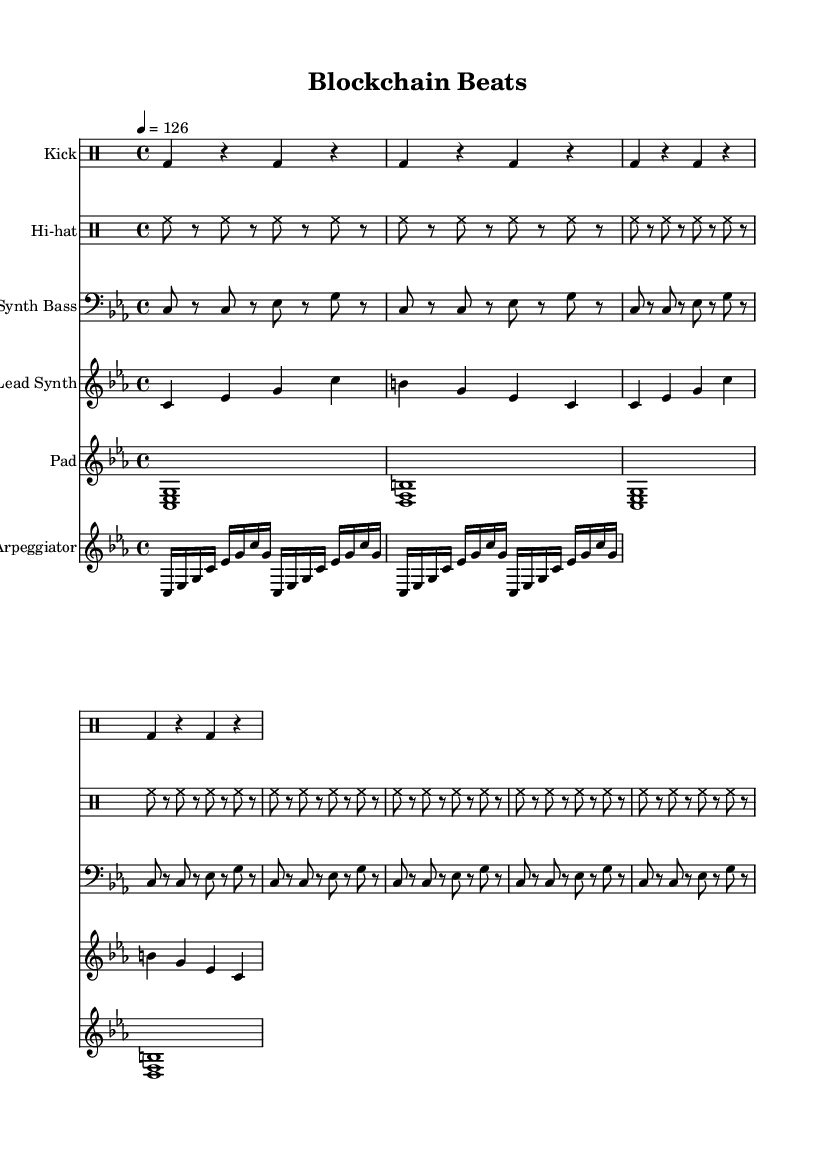What is the key signature of this music? The key signature is C minor, which indicates the presence of three flats (B♭, E♭, and A♭). You can identify it by checking the key signature section at the beginning of the sheet music.
Answer: C minor What is the time signature of this music? The time signature is 4/4, which is denoted at the beginning of the score. This means there are four beats in a measure and the quarter note gets one beat.
Answer: 4/4 What is the tempo marking for this piece? The tempo marking indicates a speed of 126 beats per minute, specified in the tempo section as "4 = 126." This refers to the quarter note, which serves as the beat unit.
Answer: 126 How many repetitions are there in the kick drum pattern? The kick drum pattern is repeated four times, as indicated by the \repeat unfold command with the number 4 in the kick drum section.
Answer: 4 What instruments are included in this piece? The piece contains five different instruments: Kick, Hi-hat, Synth Bass, Lead Synth, Pad, and Arpeggiator, as seen in the various staff headings throughout the score.
Answer: Kick, Hi-hat, Synth Bass, Lead Synth, Pad, Arpeggiator What type of harmony is primarily used in this music? The music primarily uses triadic harmony, as evidenced by the chord voicings in the Pad part, which are intersected and stacked in thirds (like the <c es g> and <b d f> chords).
Answer: Triadic harmony How many different drum components are present in the score? There are two distinct drum components in the score: the kick and the hi-hat. Both of these are presented in separate drum staff sections.
Answer: 2 